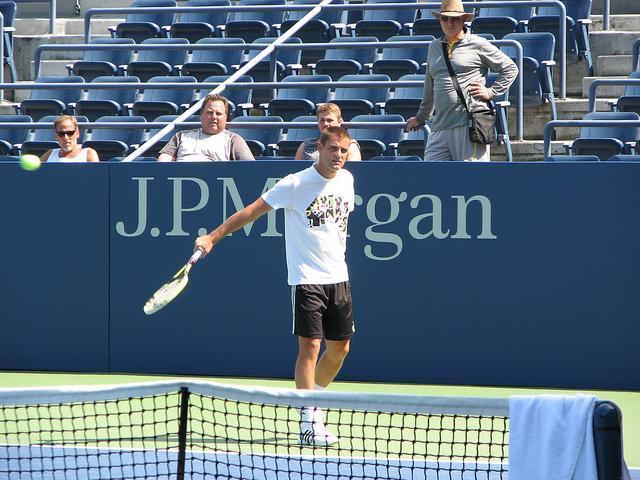How many people can be seen?
Give a very brief answer. 3. How many blue toilet seats are there?
Give a very brief answer. 0. 